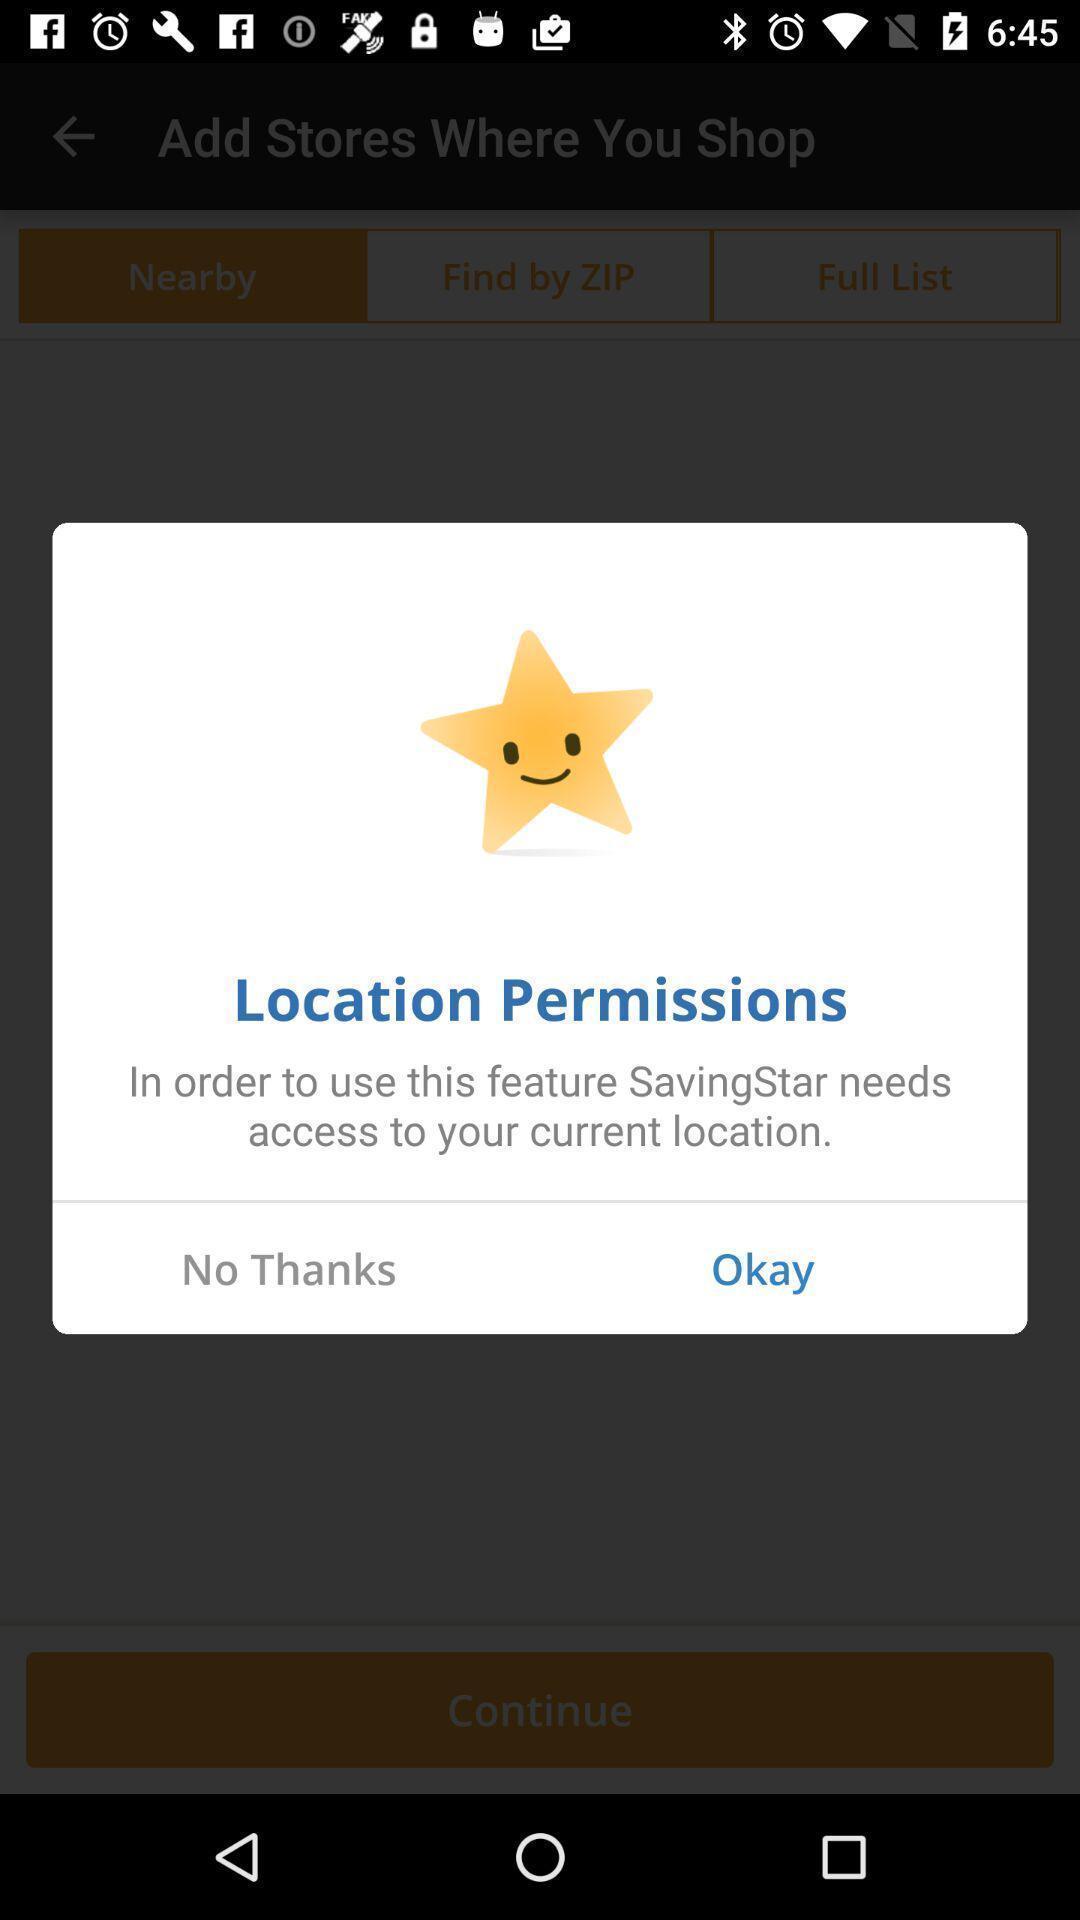Summarize the information in this screenshot. Pop-up asking permission for your current location. 